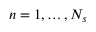<formula> <loc_0><loc_0><loc_500><loc_500>n = 1 , \dots , N _ { s }</formula> 